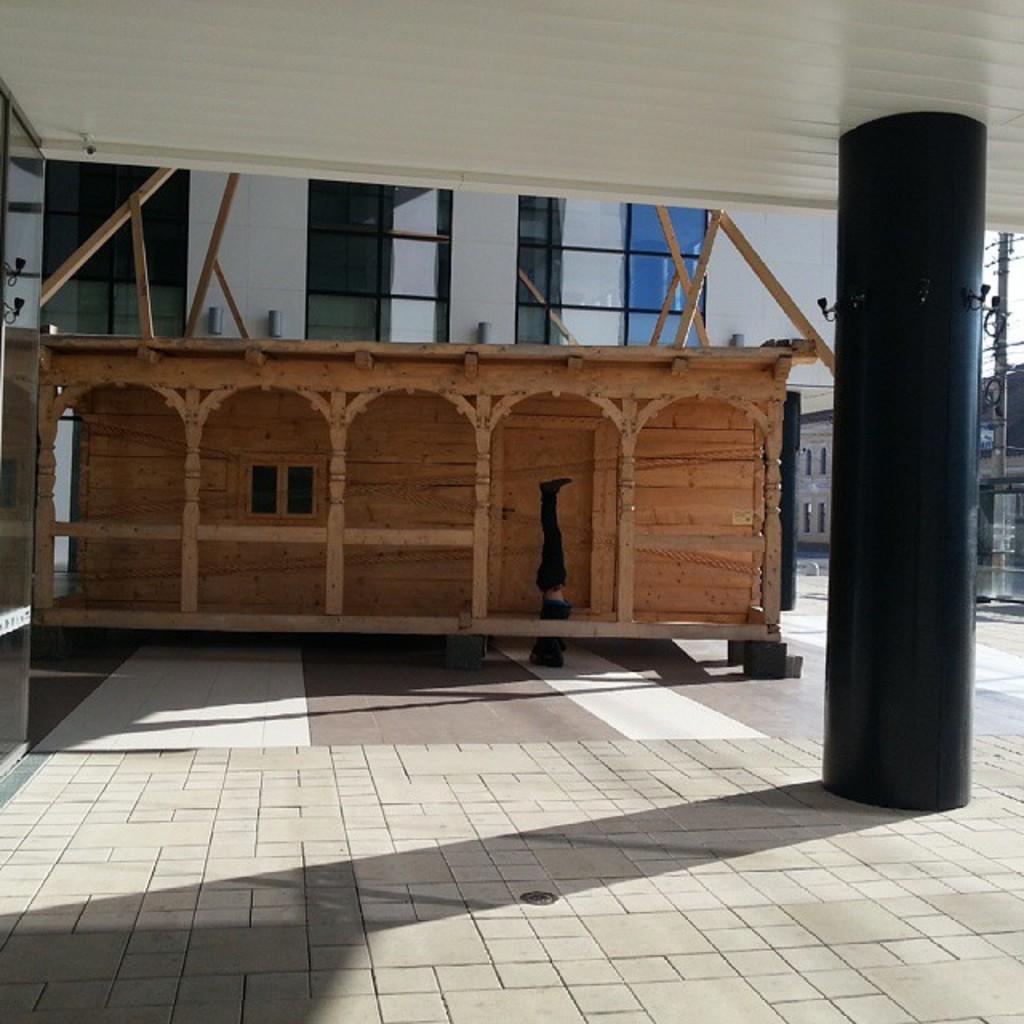Describe this image in one or two sentences. In this image I can see a person wearing black color dress, in front I can see a pillar in black color. Background I can see few buildings in white color, few electric poles and the sky is in white color. 